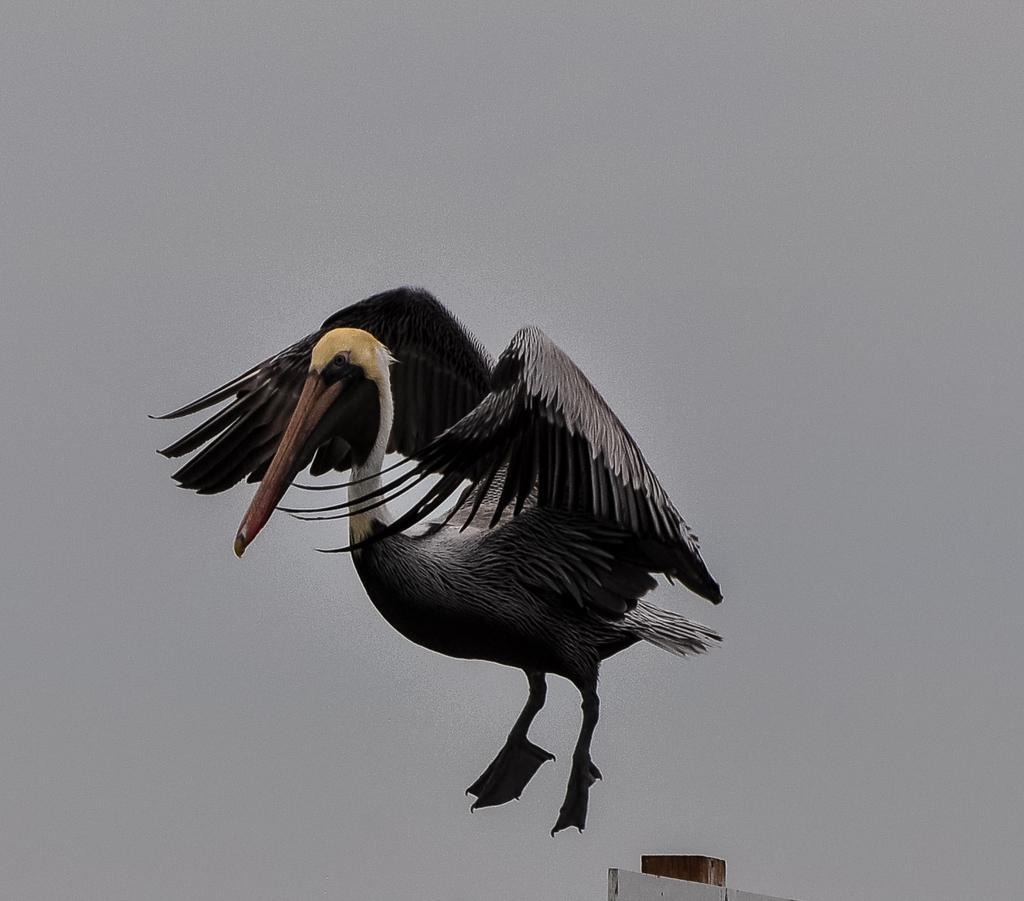Can you describe this image briefly? This is a painting. In this picture there is a painting of a flying bird and the bird is in grey color. At the bottom there is a wall. At the back there is a grey color background. 